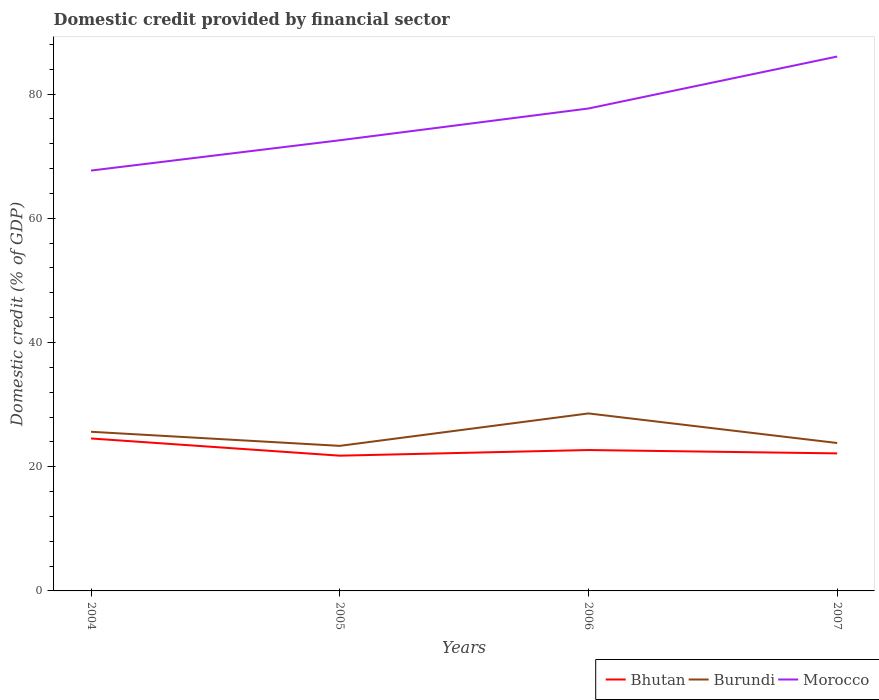How many different coloured lines are there?
Your answer should be very brief. 3. Does the line corresponding to Morocco intersect with the line corresponding to Bhutan?
Offer a terse response. No. Across all years, what is the maximum domestic credit in Burundi?
Give a very brief answer. 23.36. In which year was the domestic credit in Morocco maximum?
Ensure brevity in your answer.  2004. What is the total domestic credit in Morocco in the graph?
Offer a terse response. -9.99. What is the difference between the highest and the second highest domestic credit in Bhutan?
Keep it short and to the point. 2.77. How many lines are there?
Your answer should be very brief. 3. How many years are there in the graph?
Provide a succinct answer. 4. Are the values on the major ticks of Y-axis written in scientific E-notation?
Ensure brevity in your answer.  No. Does the graph contain any zero values?
Provide a short and direct response. No. Does the graph contain grids?
Keep it short and to the point. No. Where does the legend appear in the graph?
Give a very brief answer. Bottom right. How many legend labels are there?
Ensure brevity in your answer.  3. What is the title of the graph?
Offer a very short reply. Domestic credit provided by financial sector. Does "Bahamas" appear as one of the legend labels in the graph?
Your answer should be compact. No. What is the label or title of the X-axis?
Your answer should be very brief. Years. What is the label or title of the Y-axis?
Provide a succinct answer. Domestic credit (% of GDP). What is the Domestic credit (% of GDP) of Bhutan in 2004?
Provide a short and direct response. 24.55. What is the Domestic credit (% of GDP) in Burundi in 2004?
Provide a short and direct response. 25.63. What is the Domestic credit (% of GDP) of Morocco in 2004?
Give a very brief answer. 67.69. What is the Domestic credit (% of GDP) of Bhutan in 2005?
Your response must be concise. 21.78. What is the Domestic credit (% of GDP) in Burundi in 2005?
Keep it short and to the point. 23.36. What is the Domestic credit (% of GDP) in Morocco in 2005?
Your response must be concise. 72.57. What is the Domestic credit (% of GDP) in Bhutan in 2006?
Your response must be concise. 22.69. What is the Domestic credit (% of GDP) of Burundi in 2006?
Offer a very short reply. 28.58. What is the Domestic credit (% of GDP) in Morocco in 2006?
Your answer should be compact. 77.68. What is the Domestic credit (% of GDP) in Bhutan in 2007?
Keep it short and to the point. 22.15. What is the Domestic credit (% of GDP) of Burundi in 2007?
Provide a short and direct response. 23.82. What is the Domestic credit (% of GDP) in Morocco in 2007?
Offer a terse response. 86.05. Across all years, what is the maximum Domestic credit (% of GDP) in Bhutan?
Offer a very short reply. 24.55. Across all years, what is the maximum Domestic credit (% of GDP) of Burundi?
Offer a very short reply. 28.58. Across all years, what is the maximum Domestic credit (% of GDP) in Morocco?
Make the answer very short. 86.05. Across all years, what is the minimum Domestic credit (% of GDP) in Bhutan?
Give a very brief answer. 21.78. Across all years, what is the minimum Domestic credit (% of GDP) in Burundi?
Ensure brevity in your answer.  23.36. Across all years, what is the minimum Domestic credit (% of GDP) in Morocco?
Make the answer very short. 67.69. What is the total Domestic credit (% of GDP) of Bhutan in the graph?
Offer a very short reply. 91.16. What is the total Domestic credit (% of GDP) of Burundi in the graph?
Ensure brevity in your answer.  101.39. What is the total Domestic credit (% of GDP) of Morocco in the graph?
Offer a very short reply. 304. What is the difference between the Domestic credit (% of GDP) of Bhutan in 2004 and that in 2005?
Provide a succinct answer. 2.77. What is the difference between the Domestic credit (% of GDP) of Burundi in 2004 and that in 2005?
Provide a short and direct response. 2.27. What is the difference between the Domestic credit (% of GDP) of Morocco in 2004 and that in 2005?
Provide a succinct answer. -4.88. What is the difference between the Domestic credit (% of GDP) of Bhutan in 2004 and that in 2006?
Provide a succinct answer. 1.86. What is the difference between the Domestic credit (% of GDP) of Burundi in 2004 and that in 2006?
Offer a very short reply. -2.95. What is the difference between the Domestic credit (% of GDP) of Morocco in 2004 and that in 2006?
Your answer should be compact. -9.99. What is the difference between the Domestic credit (% of GDP) in Bhutan in 2004 and that in 2007?
Ensure brevity in your answer.  2.4. What is the difference between the Domestic credit (% of GDP) of Burundi in 2004 and that in 2007?
Your answer should be compact. 1.81. What is the difference between the Domestic credit (% of GDP) in Morocco in 2004 and that in 2007?
Offer a terse response. -18.36. What is the difference between the Domestic credit (% of GDP) in Bhutan in 2005 and that in 2006?
Offer a terse response. -0.91. What is the difference between the Domestic credit (% of GDP) of Burundi in 2005 and that in 2006?
Offer a terse response. -5.22. What is the difference between the Domestic credit (% of GDP) in Morocco in 2005 and that in 2006?
Offer a terse response. -5.12. What is the difference between the Domestic credit (% of GDP) of Bhutan in 2005 and that in 2007?
Your answer should be compact. -0.37. What is the difference between the Domestic credit (% of GDP) in Burundi in 2005 and that in 2007?
Ensure brevity in your answer.  -0.46. What is the difference between the Domestic credit (% of GDP) in Morocco in 2005 and that in 2007?
Ensure brevity in your answer.  -13.48. What is the difference between the Domestic credit (% of GDP) in Bhutan in 2006 and that in 2007?
Offer a terse response. 0.54. What is the difference between the Domestic credit (% of GDP) of Burundi in 2006 and that in 2007?
Keep it short and to the point. 4.76. What is the difference between the Domestic credit (% of GDP) of Morocco in 2006 and that in 2007?
Your answer should be very brief. -8.37. What is the difference between the Domestic credit (% of GDP) in Bhutan in 2004 and the Domestic credit (% of GDP) in Burundi in 2005?
Give a very brief answer. 1.19. What is the difference between the Domestic credit (% of GDP) in Bhutan in 2004 and the Domestic credit (% of GDP) in Morocco in 2005?
Your response must be concise. -48.02. What is the difference between the Domestic credit (% of GDP) of Burundi in 2004 and the Domestic credit (% of GDP) of Morocco in 2005?
Provide a succinct answer. -46.94. What is the difference between the Domestic credit (% of GDP) in Bhutan in 2004 and the Domestic credit (% of GDP) in Burundi in 2006?
Your response must be concise. -4.03. What is the difference between the Domestic credit (% of GDP) in Bhutan in 2004 and the Domestic credit (% of GDP) in Morocco in 2006?
Your answer should be compact. -53.14. What is the difference between the Domestic credit (% of GDP) in Burundi in 2004 and the Domestic credit (% of GDP) in Morocco in 2006?
Offer a very short reply. -52.06. What is the difference between the Domestic credit (% of GDP) in Bhutan in 2004 and the Domestic credit (% of GDP) in Burundi in 2007?
Keep it short and to the point. 0.73. What is the difference between the Domestic credit (% of GDP) of Bhutan in 2004 and the Domestic credit (% of GDP) of Morocco in 2007?
Provide a succinct answer. -61.5. What is the difference between the Domestic credit (% of GDP) of Burundi in 2004 and the Domestic credit (% of GDP) of Morocco in 2007?
Keep it short and to the point. -60.42. What is the difference between the Domestic credit (% of GDP) of Bhutan in 2005 and the Domestic credit (% of GDP) of Burundi in 2006?
Your answer should be compact. -6.8. What is the difference between the Domestic credit (% of GDP) in Bhutan in 2005 and the Domestic credit (% of GDP) in Morocco in 2006?
Provide a succinct answer. -55.91. What is the difference between the Domestic credit (% of GDP) of Burundi in 2005 and the Domestic credit (% of GDP) of Morocco in 2006?
Give a very brief answer. -54.32. What is the difference between the Domestic credit (% of GDP) of Bhutan in 2005 and the Domestic credit (% of GDP) of Burundi in 2007?
Provide a short and direct response. -2.04. What is the difference between the Domestic credit (% of GDP) of Bhutan in 2005 and the Domestic credit (% of GDP) of Morocco in 2007?
Your answer should be compact. -64.27. What is the difference between the Domestic credit (% of GDP) in Burundi in 2005 and the Domestic credit (% of GDP) in Morocco in 2007?
Your response must be concise. -62.69. What is the difference between the Domestic credit (% of GDP) in Bhutan in 2006 and the Domestic credit (% of GDP) in Burundi in 2007?
Make the answer very short. -1.13. What is the difference between the Domestic credit (% of GDP) of Bhutan in 2006 and the Domestic credit (% of GDP) of Morocco in 2007?
Provide a short and direct response. -63.36. What is the difference between the Domestic credit (% of GDP) of Burundi in 2006 and the Domestic credit (% of GDP) of Morocco in 2007?
Your response must be concise. -57.47. What is the average Domestic credit (% of GDP) in Bhutan per year?
Ensure brevity in your answer.  22.79. What is the average Domestic credit (% of GDP) of Burundi per year?
Your response must be concise. 25.35. What is the average Domestic credit (% of GDP) of Morocco per year?
Offer a terse response. 76. In the year 2004, what is the difference between the Domestic credit (% of GDP) in Bhutan and Domestic credit (% of GDP) in Burundi?
Make the answer very short. -1.08. In the year 2004, what is the difference between the Domestic credit (% of GDP) in Bhutan and Domestic credit (% of GDP) in Morocco?
Your answer should be compact. -43.14. In the year 2004, what is the difference between the Domestic credit (% of GDP) in Burundi and Domestic credit (% of GDP) in Morocco?
Provide a succinct answer. -42.06. In the year 2005, what is the difference between the Domestic credit (% of GDP) of Bhutan and Domestic credit (% of GDP) of Burundi?
Your answer should be compact. -1.58. In the year 2005, what is the difference between the Domestic credit (% of GDP) of Bhutan and Domestic credit (% of GDP) of Morocco?
Your answer should be very brief. -50.79. In the year 2005, what is the difference between the Domestic credit (% of GDP) in Burundi and Domestic credit (% of GDP) in Morocco?
Your answer should be very brief. -49.21. In the year 2006, what is the difference between the Domestic credit (% of GDP) of Bhutan and Domestic credit (% of GDP) of Burundi?
Offer a terse response. -5.89. In the year 2006, what is the difference between the Domestic credit (% of GDP) in Bhutan and Domestic credit (% of GDP) in Morocco?
Make the answer very short. -55. In the year 2006, what is the difference between the Domestic credit (% of GDP) of Burundi and Domestic credit (% of GDP) of Morocco?
Your answer should be compact. -49.1. In the year 2007, what is the difference between the Domestic credit (% of GDP) of Bhutan and Domestic credit (% of GDP) of Burundi?
Your answer should be compact. -1.67. In the year 2007, what is the difference between the Domestic credit (% of GDP) of Bhutan and Domestic credit (% of GDP) of Morocco?
Ensure brevity in your answer.  -63.91. In the year 2007, what is the difference between the Domestic credit (% of GDP) in Burundi and Domestic credit (% of GDP) in Morocco?
Give a very brief answer. -62.23. What is the ratio of the Domestic credit (% of GDP) in Bhutan in 2004 to that in 2005?
Your answer should be very brief. 1.13. What is the ratio of the Domestic credit (% of GDP) in Burundi in 2004 to that in 2005?
Offer a very short reply. 1.1. What is the ratio of the Domestic credit (% of GDP) in Morocco in 2004 to that in 2005?
Give a very brief answer. 0.93. What is the ratio of the Domestic credit (% of GDP) in Bhutan in 2004 to that in 2006?
Keep it short and to the point. 1.08. What is the ratio of the Domestic credit (% of GDP) of Burundi in 2004 to that in 2006?
Make the answer very short. 0.9. What is the ratio of the Domestic credit (% of GDP) in Morocco in 2004 to that in 2006?
Your answer should be very brief. 0.87. What is the ratio of the Domestic credit (% of GDP) in Bhutan in 2004 to that in 2007?
Offer a terse response. 1.11. What is the ratio of the Domestic credit (% of GDP) in Burundi in 2004 to that in 2007?
Provide a succinct answer. 1.08. What is the ratio of the Domestic credit (% of GDP) of Morocco in 2004 to that in 2007?
Your response must be concise. 0.79. What is the ratio of the Domestic credit (% of GDP) of Bhutan in 2005 to that in 2006?
Your response must be concise. 0.96. What is the ratio of the Domestic credit (% of GDP) in Burundi in 2005 to that in 2006?
Your answer should be compact. 0.82. What is the ratio of the Domestic credit (% of GDP) in Morocco in 2005 to that in 2006?
Your answer should be very brief. 0.93. What is the ratio of the Domestic credit (% of GDP) of Bhutan in 2005 to that in 2007?
Offer a terse response. 0.98. What is the ratio of the Domestic credit (% of GDP) in Burundi in 2005 to that in 2007?
Provide a short and direct response. 0.98. What is the ratio of the Domestic credit (% of GDP) of Morocco in 2005 to that in 2007?
Provide a short and direct response. 0.84. What is the ratio of the Domestic credit (% of GDP) in Bhutan in 2006 to that in 2007?
Ensure brevity in your answer.  1.02. What is the ratio of the Domestic credit (% of GDP) in Burundi in 2006 to that in 2007?
Your answer should be very brief. 1.2. What is the ratio of the Domestic credit (% of GDP) of Morocco in 2006 to that in 2007?
Your answer should be very brief. 0.9. What is the difference between the highest and the second highest Domestic credit (% of GDP) in Bhutan?
Give a very brief answer. 1.86. What is the difference between the highest and the second highest Domestic credit (% of GDP) of Burundi?
Provide a succinct answer. 2.95. What is the difference between the highest and the second highest Domestic credit (% of GDP) of Morocco?
Ensure brevity in your answer.  8.37. What is the difference between the highest and the lowest Domestic credit (% of GDP) of Bhutan?
Give a very brief answer. 2.77. What is the difference between the highest and the lowest Domestic credit (% of GDP) of Burundi?
Your answer should be compact. 5.22. What is the difference between the highest and the lowest Domestic credit (% of GDP) of Morocco?
Your response must be concise. 18.36. 